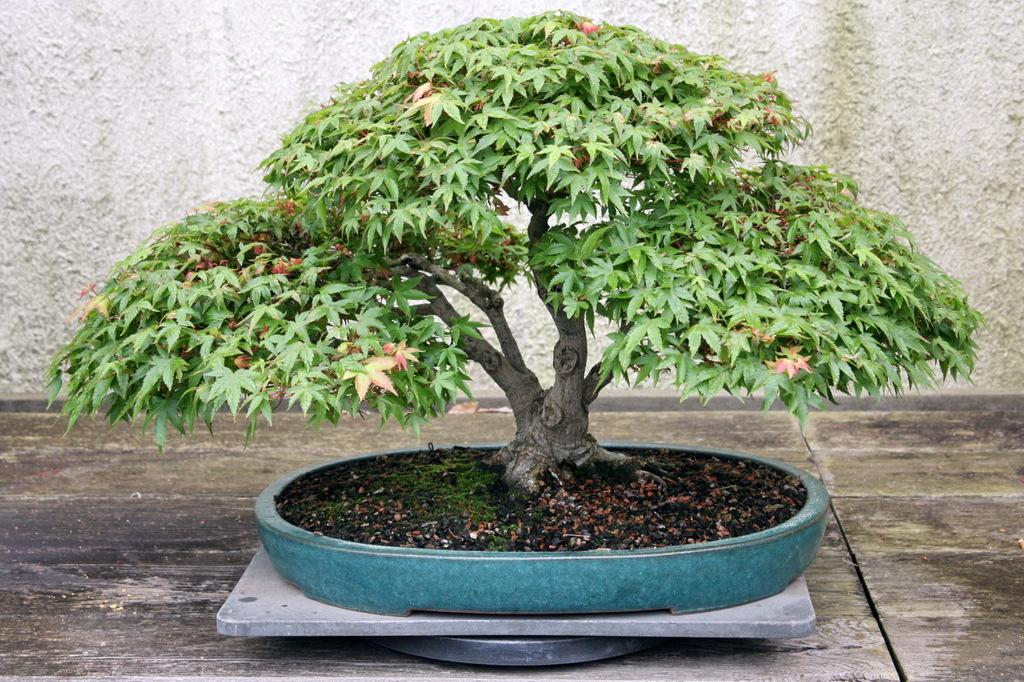What type of plant is in the image? There is a small tree in the image. Where is the small tree located? The small tree is in a pot. What can be seen in the background of the image? There is a wall in the background of the image. What type of mark can be seen on the tree's bark in the image? There is no mark visible on the tree's bark in the image. Are there any teeth present on the tree in the image? Trees do not have teeth, so there are no teeth present on the tree in the image. 